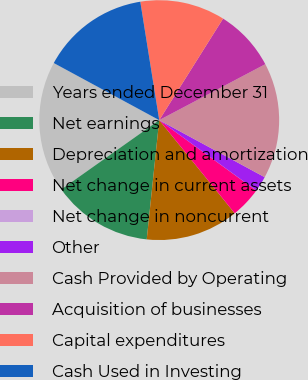<chart> <loc_0><loc_0><loc_500><loc_500><pie_chart><fcel>Years ended December 31<fcel>Net earnings<fcel>Depreciation and amortization<fcel>Net change in current assets<fcel>Net change in noncurrent<fcel>Other<fcel>Cash Provided by Operating<fcel>Acquisition of businesses<fcel>Capital expenditures<fcel>Cash Used in Investing<nl><fcel>17.7%<fcel>13.54%<fcel>12.5%<fcel>4.17%<fcel>0.01%<fcel>2.09%<fcel>15.62%<fcel>8.34%<fcel>11.46%<fcel>14.58%<nl></chart> 